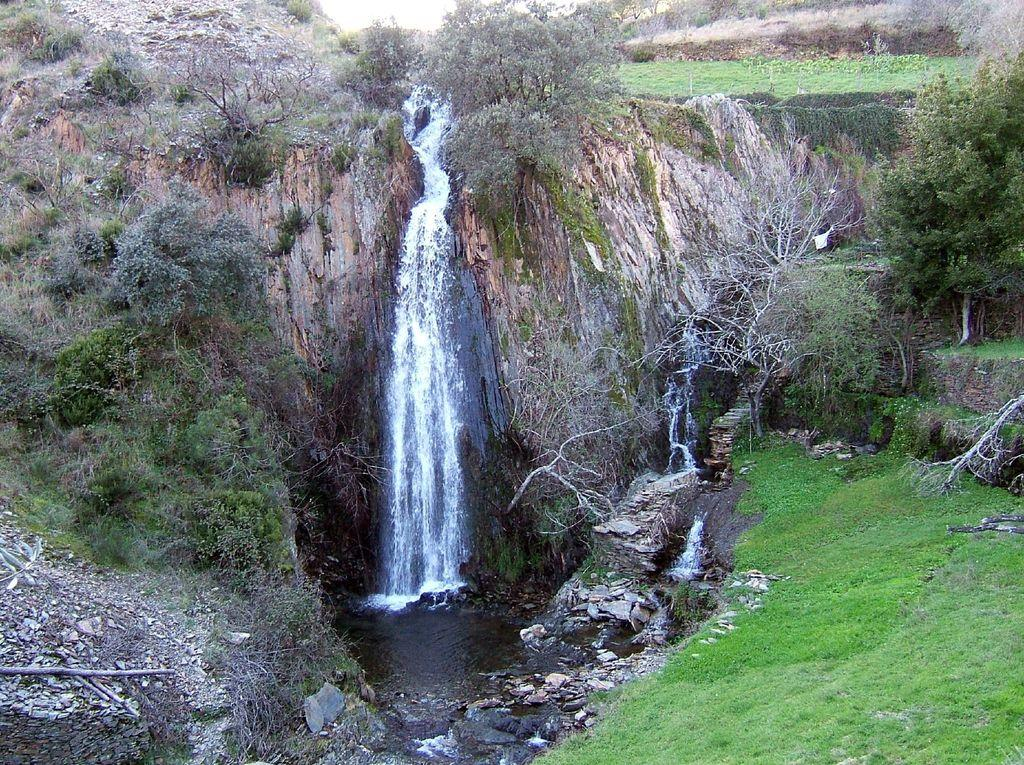What natural feature is the main subject of the image? There is a waterfall in the image. What type of landscape can be seen in the image? There are hills, trees, stones, and grass in the image. What is the color of the sky in the image? The sky is white in the image. Can you tell me how many times the person needs to brake while swimming in the image? There is no person swimming in the image, and therefore no need to brake. 